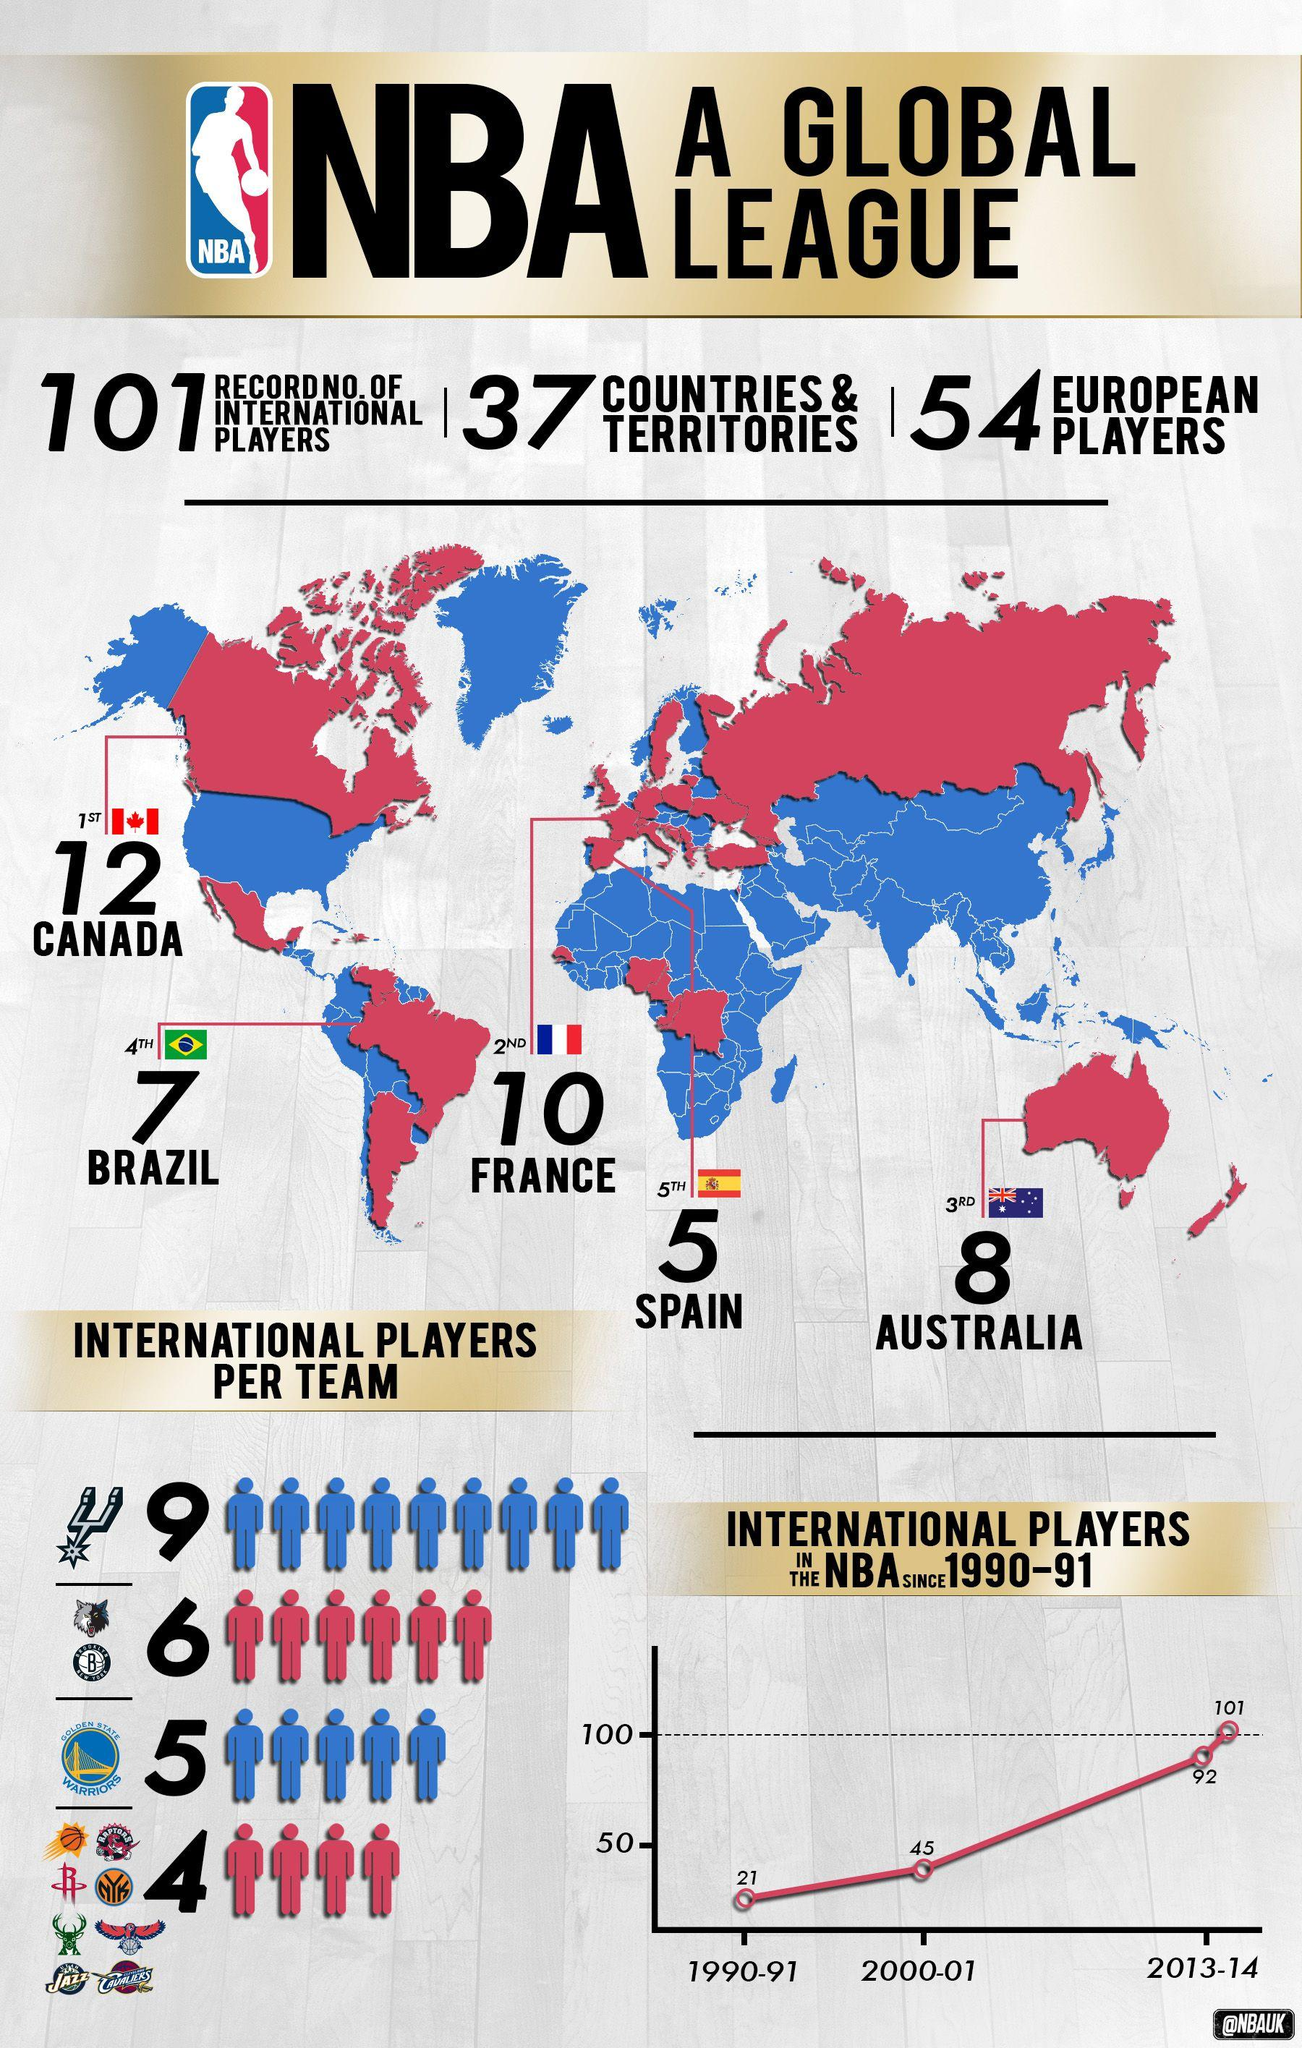Identify some key points in this picture. There were 66 international players in the NBA during the seasons of 1990-91 and 2000-01. 